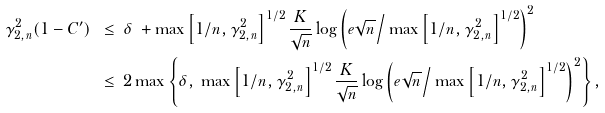<formula> <loc_0><loc_0><loc_500><loc_500>\gamma _ { 2 , n } ^ { 2 } ( 1 - C ^ { \prime } ) \ & \leq \ \delta \ + \max \left [ 1 / n , \gamma _ { 2 , n } ^ { 2 } \right ] ^ { 1 / 2 } \frac { K } { \sqrt { n } } \log \left ( e \sqrt { n } \Big / \max \left [ 1 / n , \gamma _ { 2 , n } ^ { 2 } \right ] ^ { 1 / 2 } \right ) ^ { 2 } \\ & \leq \ 2 \max \left \{ \delta , \ \max \left [ 1 / n , \gamma _ { 2 , n } ^ { 2 } \right ] ^ { 1 / 2 } \frac { K } { \sqrt { n } } \log \left ( e \sqrt { n } \Big / \max \left [ 1 / n , \gamma _ { 2 , n } ^ { 2 } \right ] ^ { 1 / 2 } \right ) ^ { 2 } \right \} ,</formula> 